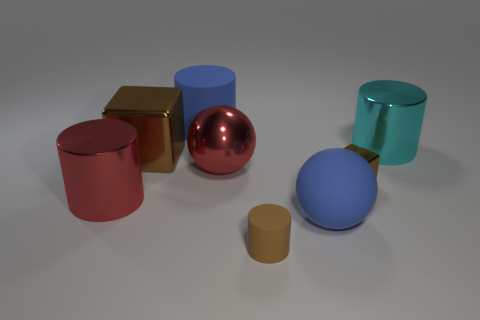How many objects are large blue matte things on the left side of the brown cylinder or brown things to the left of the brown matte object?
Ensure brevity in your answer.  2. What is the shape of the cyan shiny object?
Ensure brevity in your answer.  Cylinder. How many other objects are the same material as the big blue cylinder?
Ensure brevity in your answer.  2. There is another brown object that is the same shape as the big brown metal object; what is its size?
Offer a very short reply. Small. What material is the big cyan thing that is right of the blue matte thing behind the large metallic thing to the right of the small brown shiny thing made of?
Ensure brevity in your answer.  Metal. Are there any large purple matte cubes?
Give a very brief answer. No. Do the large matte cylinder and the big metallic thing that is behind the big metallic cube have the same color?
Your response must be concise. No. What is the color of the large block?
Offer a terse response. Brown. Is there any other thing that has the same shape as the tiny brown metal object?
Offer a terse response. Yes. What is the color of the small thing that is the same shape as the big cyan metallic thing?
Make the answer very short. Brown. 